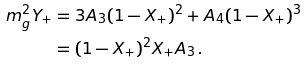<formula> <loc_0><loc_0><loc_500><loc_500>m _ { g } ^ { 2 } Y _ { + } & = 3 A _ { 3 } ( 1 - X _ { + } ) ^ { 2 } + A _ { 4 } ( 1 - X _ { + } ) ^ { 3 } \\ & = ( 1 - X _ { + } ) ^ { 2 } X _ { + } A _ { 3 } \, .</formula> 